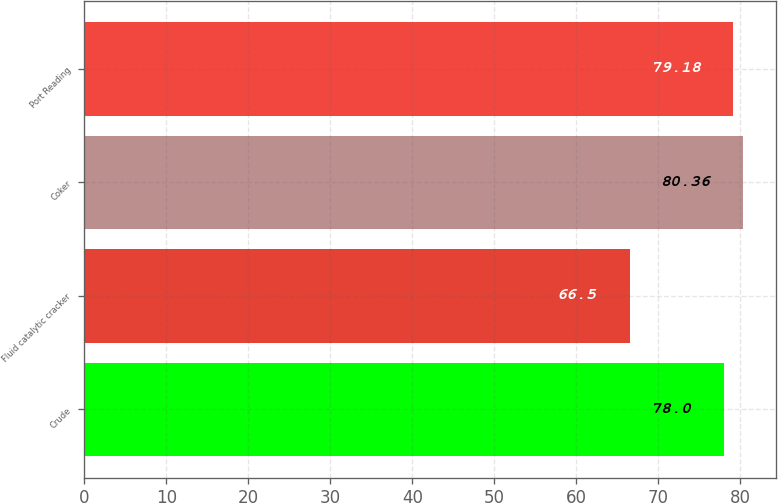<chart> <loc_0><loc_0><loc_500><loc_500><bar_chart><fcel>Crude<fcel>Fluid catalytic cracker<fcel>Coker<fcel>Port Reading<nl><fcel>78<fcel>66.5<fcel>80.36<fcel>79.18<nl></chart> 